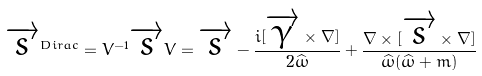<formula> <loc_0><loc_0><loc_500><loc_500>\overrightarrow { s } ^ { D i r a c } = V ^ { - 1 } \overrightarrow { s } V = \overrightarrow { s } - \frac { i [ \overrightarrow { \gamma } \times \nabla ] } { 2 \widehat { \omega } } + \frac { \nabla \times [ \overrightarrow { s } \times \nabla ] } { \widehat { \omega } ( \widehat { \omega } + m ) }</formula> 